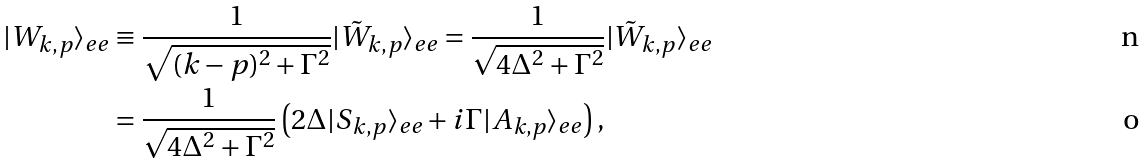Convert formula to latex. <formula><loc_0><loc_0><loc_500><loc_500>| W _ { k , p } \rangle _ { e e } & \equiv \frac { 1 } { \sqrt { ( k - p ) ^ { 2 } + \Gamma ^ { 2 } } } | \tilde { W } _ { k , p } \rangle _ { e e } = \frac { 1 } { \sqrt { 4 \Delta ^ { 2 } + \Gamma ^ { 2 } } } | \tilde { W } _ { k , p } \rangle _ { e e } \\ & = \frac { 1 } { \sqrt { 4 \Delta ^ { 2 } + \Gamma ^ { 2 } } } \left ( 2 \Delta | S _ { k , p } \rangle _ { e e } + i \Gamma | A _ { k , p } \rangle _ { e e } \right ) ,</formula> 